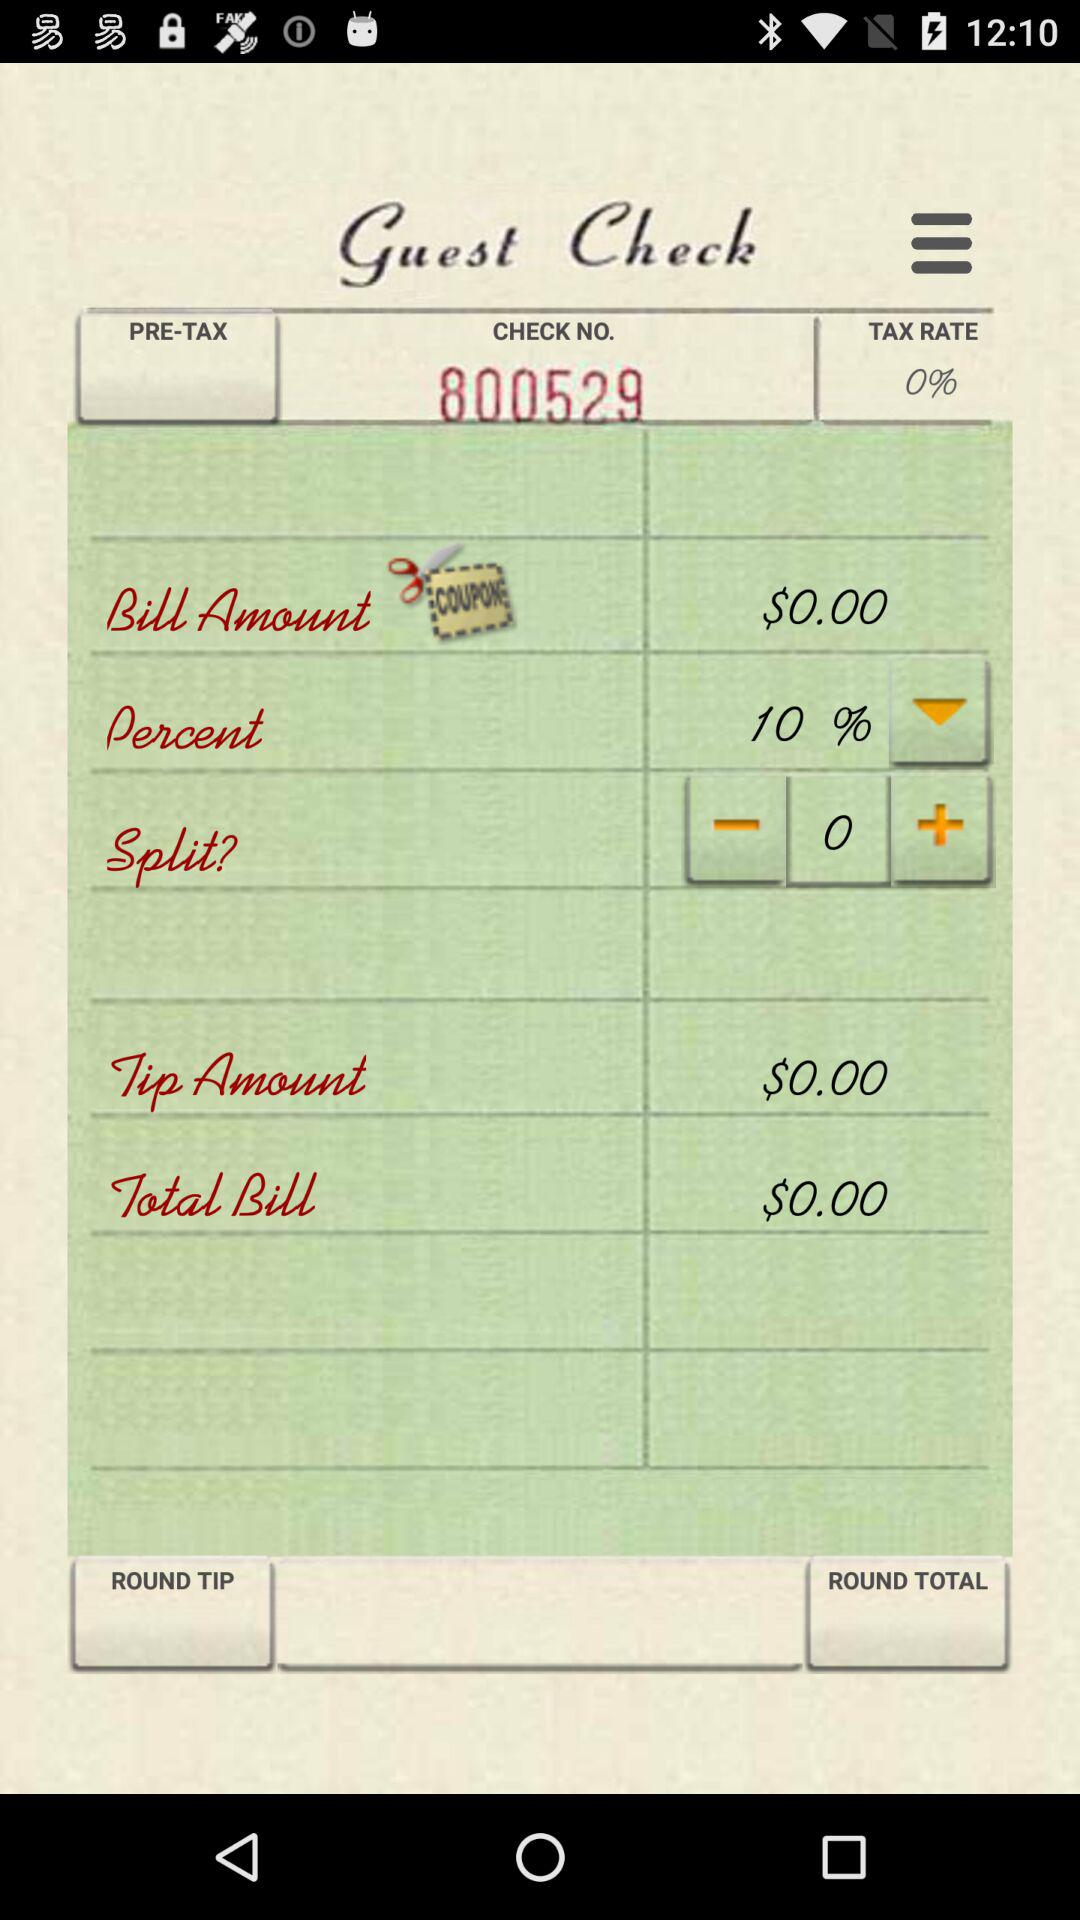What is the discount percentage? The discount percentage is 10. 